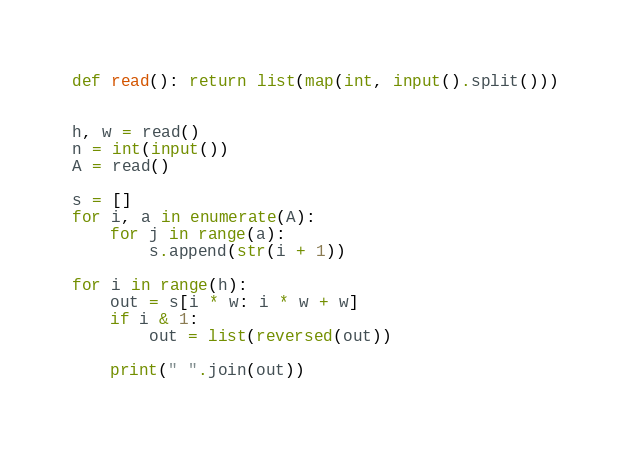Convert code to text. <code><loc_0><loc_0><loc_500><loc_500><_Python_>def read(): return list(map(int, input().split()))


h, w = read()
n = int(input())
A = read()

s = []
for i, a in enumerate(A):
    for j in range(a):
        s.append(str(i + 1))

for i in range(h):
    out = s[i * w: i * w + w]
    if i & 1:
        out = list(reversed(out))

    print(" ".join(out))</code> 